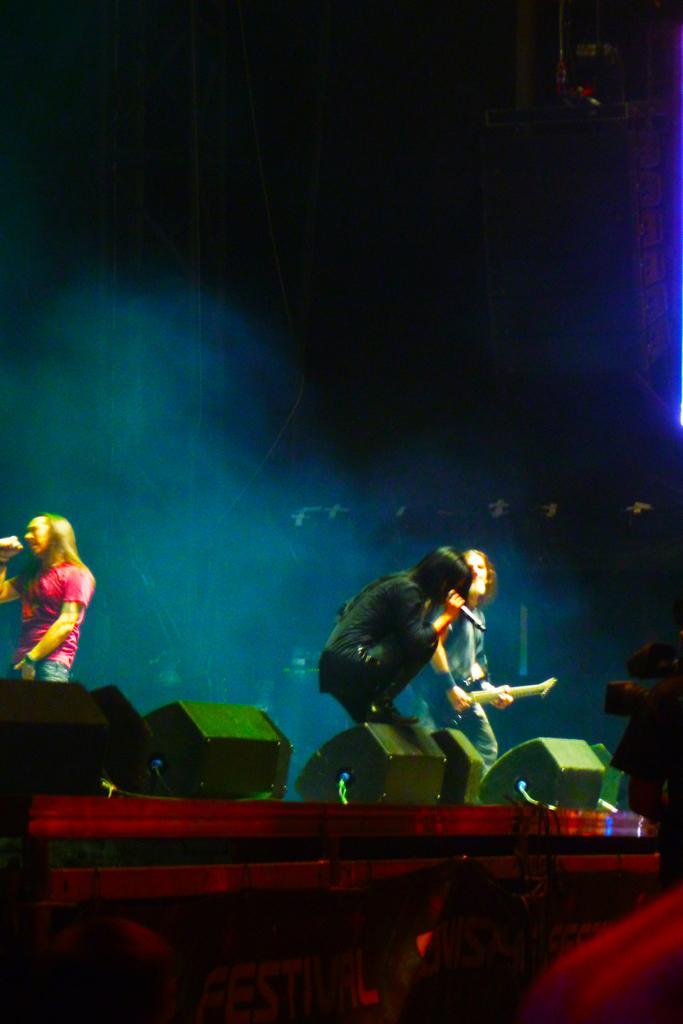How would you summarize this image in a sentence or two? In this image we can see people holding mics. There are speakers. At the bottom of the image there are people. In the background of the image there are rods. 